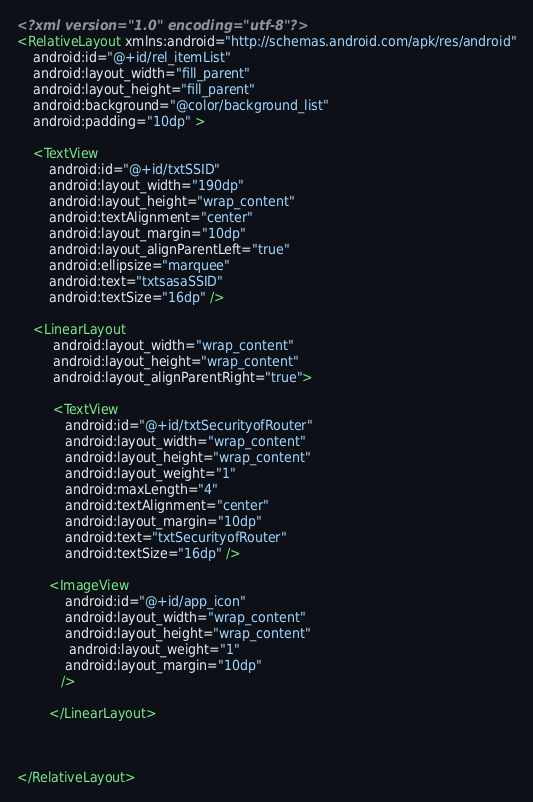Convert code to text. <code><loc_0><loc_0><loc_500><loc_500><_XML_><?xml version="1.0" encoding="utf-8"?>
<RelativeLayout xmlns:android="http://schemas.android.com/apk/res/android"
    android:id="@+id/rel_itemList"
    android:layout_width="fill_parent"
    android:layout_height="fill_parent"
    android:background="@color/background_list"
    android:padding="10dp" >
    
    <TextView
        android:id="@+id/txtSSID"
        android:layout_width="190dp"
        android:layout_height="wrap_content"
        android:textAlignment="center"
        android:layout_margin="10dp"
        android:layout_alignParentLeft="true"
       	android:ellipsize="marquee"
       	android:text="txtsasaSSID"
        android:textSize="16dp" />
    
    <LinearLayout 
         android:layout_width="wrap_content"
         android:layout_height="wrap_content"
         android:layout_alignParentRight="true">
         
	     <TextView
	        android:id="@+id/txtSecurityofRouter"
	        android:layout_width="wrap_content"
	        android:layout_height="wrap_content"
	        android:layout_weight="1"
	        android:maxLength="4"
	        android:textAlignment="center"
	        android:layout_margin="10dp"
	        android:text="txtSecurityofRouter"
	        android:textSize="16dp" />
	    
	    <ImageView
	        android:id="@+id/app_icon"
	        android:layout_width="wrap_content"
	        android:layout_height="wrap_content"
	         android:layout_weight="1"
	        android:layout_margin="10dp"
	       />
	        
        </LinearLayout>
    
    

</RelativeLayout></code> 